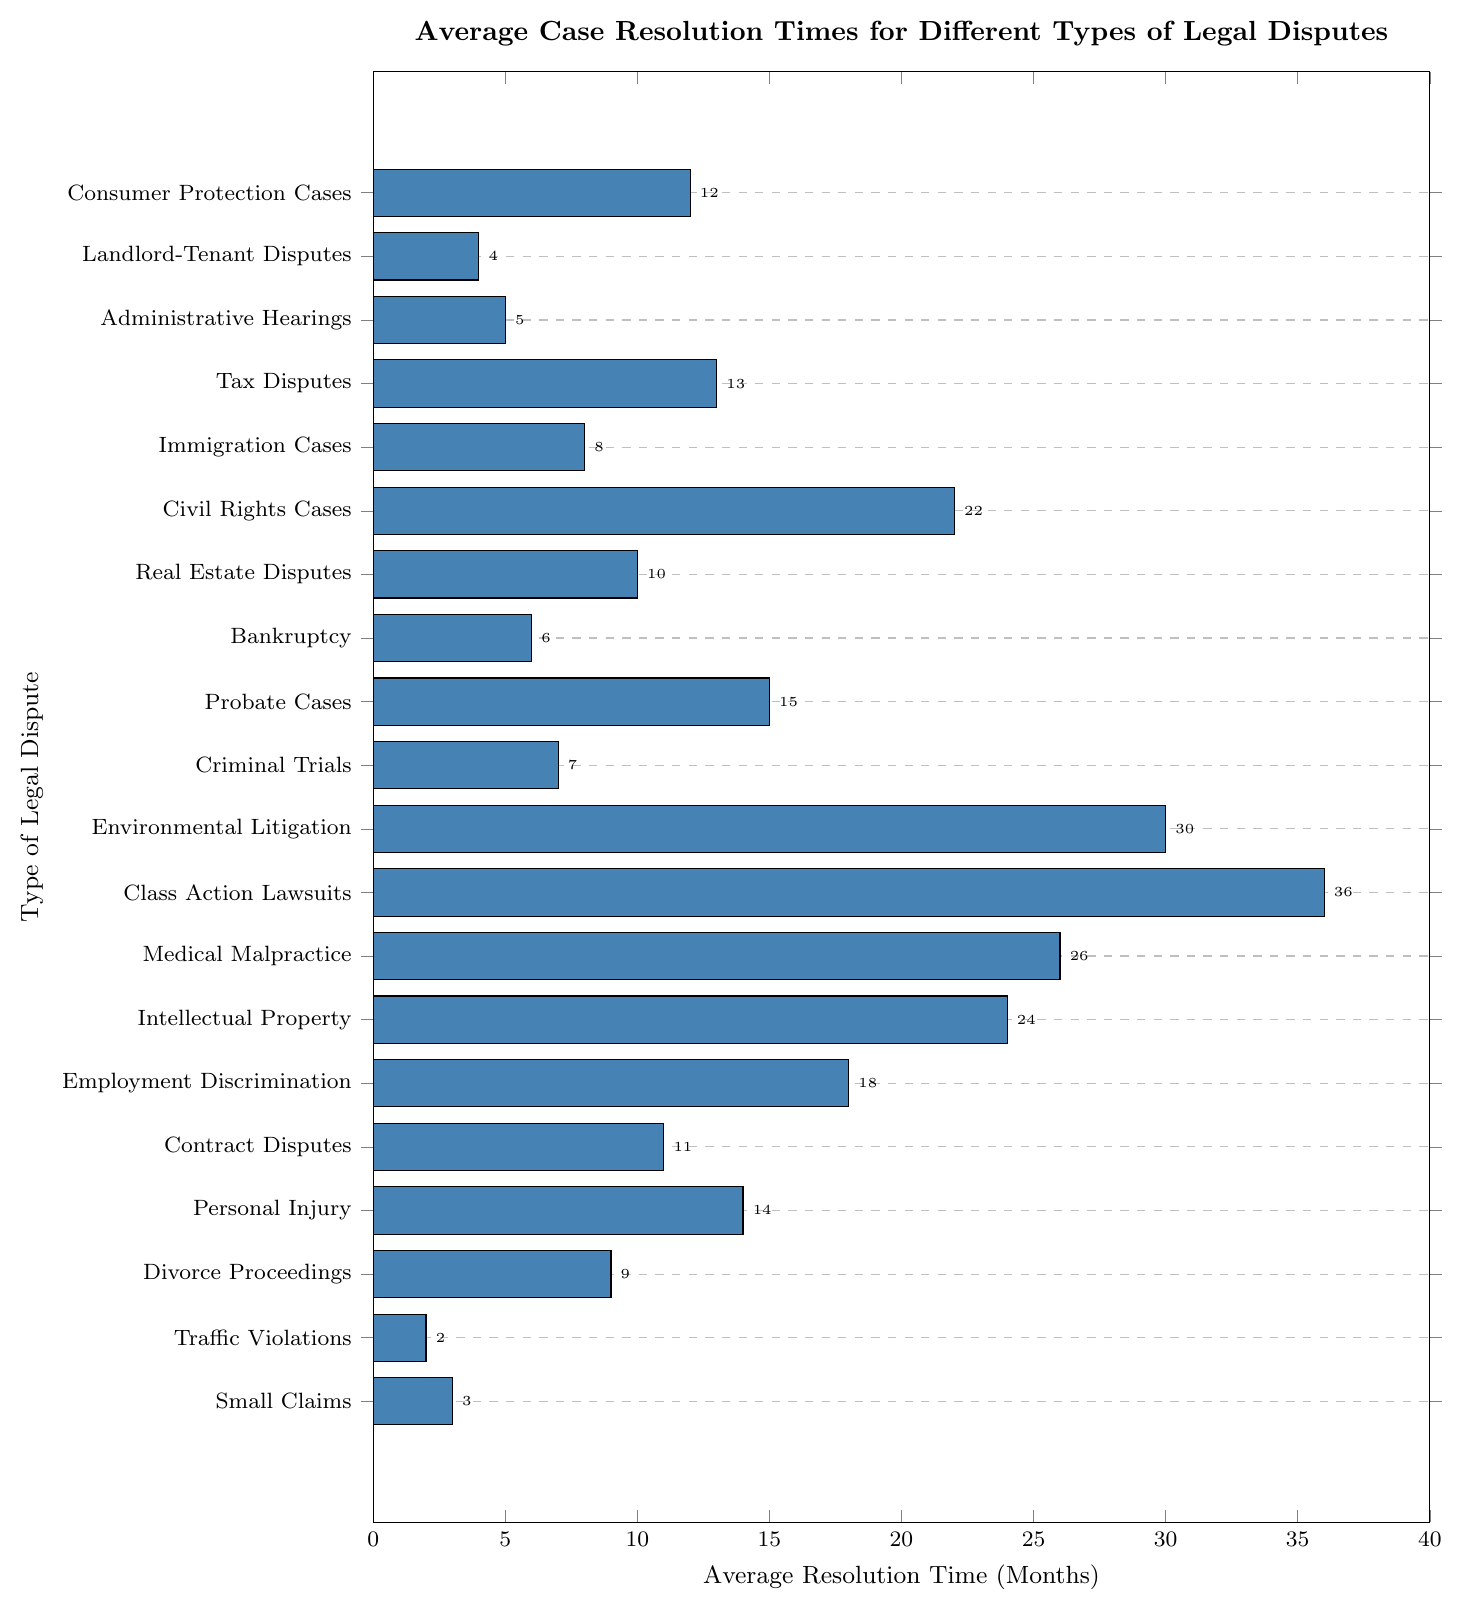What's the average resolution time for Small Claims and Traffic Violations combined? To find the combined average, we sum the average resolution times for Small Claims (3 months) and Traffic Violations (2 months), then divide by the number of dispute types (2). So, (3 + 2) / 2 = 2.5 months.
Answer: 2.5 months Which legal dispute type has the longest average resolution time? The bar representing Class Action Lawsuits extends the farthest along the x-axis, indicating the longest average resolution time, which is 36 months.
Answer: Class Action Lawsuits Is the average resolution time of Criminal Trials longer than that of Bankruptcy cases? The bar for Criminal Trials points to 7 months, while the bar for Bankruptcy points to 6 months. Since 7 months is longer than 6 months, Criminal Trials take longer on average.
Answer: Yes How many legal dispute types have an average resolution time of 10 months or more? We count the bars that extend to 10 months or more: Real Estate Disputes (10), Consumer Protection Cases (12), Tax Disputes (13), Personal Injury (14), Probate Cases (15), Employment Discrimination (18), Civil Rights Cases (22), Intellectual Property (24), Medical Malpractice (26), Environmental Litigation (30), and Class Action Lawsuits (36). That's 11 types.
Answer: 11 types What is the difference in average resolution times between Divorce Proceedings and Real Estate Disputes? The bar for Divorce Proceedings indicates 9 months, and the bar for Real Estate Disputes indicates 10 months. The difference is 10 - 9 = 1 month.
Answer: 1 month Which legal dispute type has an identical average resolution time as Personal Injury? The bar for Personal Injury shows 14 months. Tax Disputes also show 14 months. No other bars align with 14 months, indicating they have identical average resolution times.
Answer: None What’s the duration difference between the shortest and the longest average resolution times? The shortest resolution time is for Traffic Violations (2 months) and the longest is for Class Action Lawsuits (36 months). The difference is 36 - 2 = 34 months.
Answer: 34 months Does Environmental Litigation take longer to resolve, on average, than Probate Cases? The bar for Environmental Litigation shows 30 months, whereas the bar for Probate Cases shows 15 months. Since 30 is greater than 15, Environmental Litigation takes longer.
Answer: Yes What is the sum of the average resolution times for Administrative Hearings, Landlord-Tenant Disputes, and Small Claims? The average resolution times are: Administrative Hearings = 5 months, Landlord-Tenant Disputes = 4 months, Small Claims = 3 months. Summing them: 5 + 4 + 3 = 12 months.
Answer: 12 months Which is resolved faster on average: Consumer Protection Cases or Employment Discrimination cases? The bar for Consumer Protection Cases extends to 12 months, while the bar for Employment Discrimination extends to 18 months. Since 12 is less than 18, Consumer Protection Cases are resolved faster.
Answer: Consumer Protection Cases 